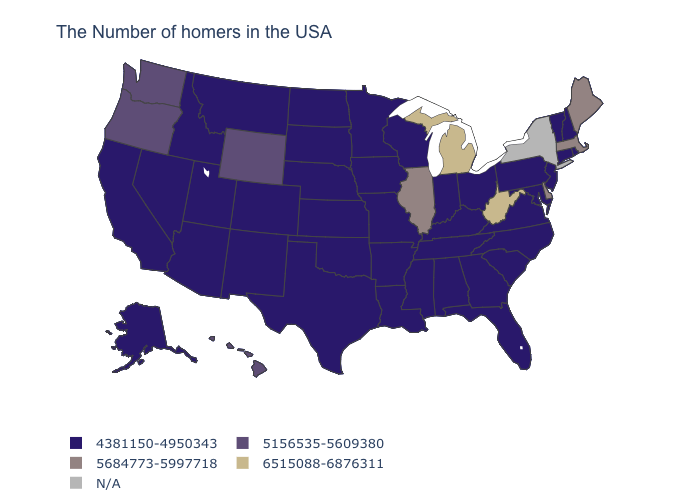What is the value of Oklahoma?
Short answer required. 4381150-4950343. Does Washington have the highest value in the West?
Keep it brief. Yes. Among the states that border California , does Oregon have the lowest value?
Be succinct. No. Which states have the highest value in the USA?
Quick response, please. West Virginia, Michigan. What is the value of Montana?
Quick response, please. 4381150-4950343. Among the states that border Vermont , does New Hampshire have the highest value?
Keep it brief. No. What is the value of Arkansas?
Answer briefly. 4381150-4950343. What is the value of Connecticut?
Write a very short answer. 4381150-4950343. Name the states that have a value in the range N/A?
Concise answer only. New York. Among the states that border Missouri , which have the highest value?
Be succinct. Illinois. Name the states that have a value in the range 5684773-5997718?
Answer briefly. Maine, Massachusetts, Delaware, Illinois. Among the states that border New Jersey , which have the highest value?
Short answer required. Delaware. What is the highest value in the USA?
Short answer required. 6515088-6876311. 